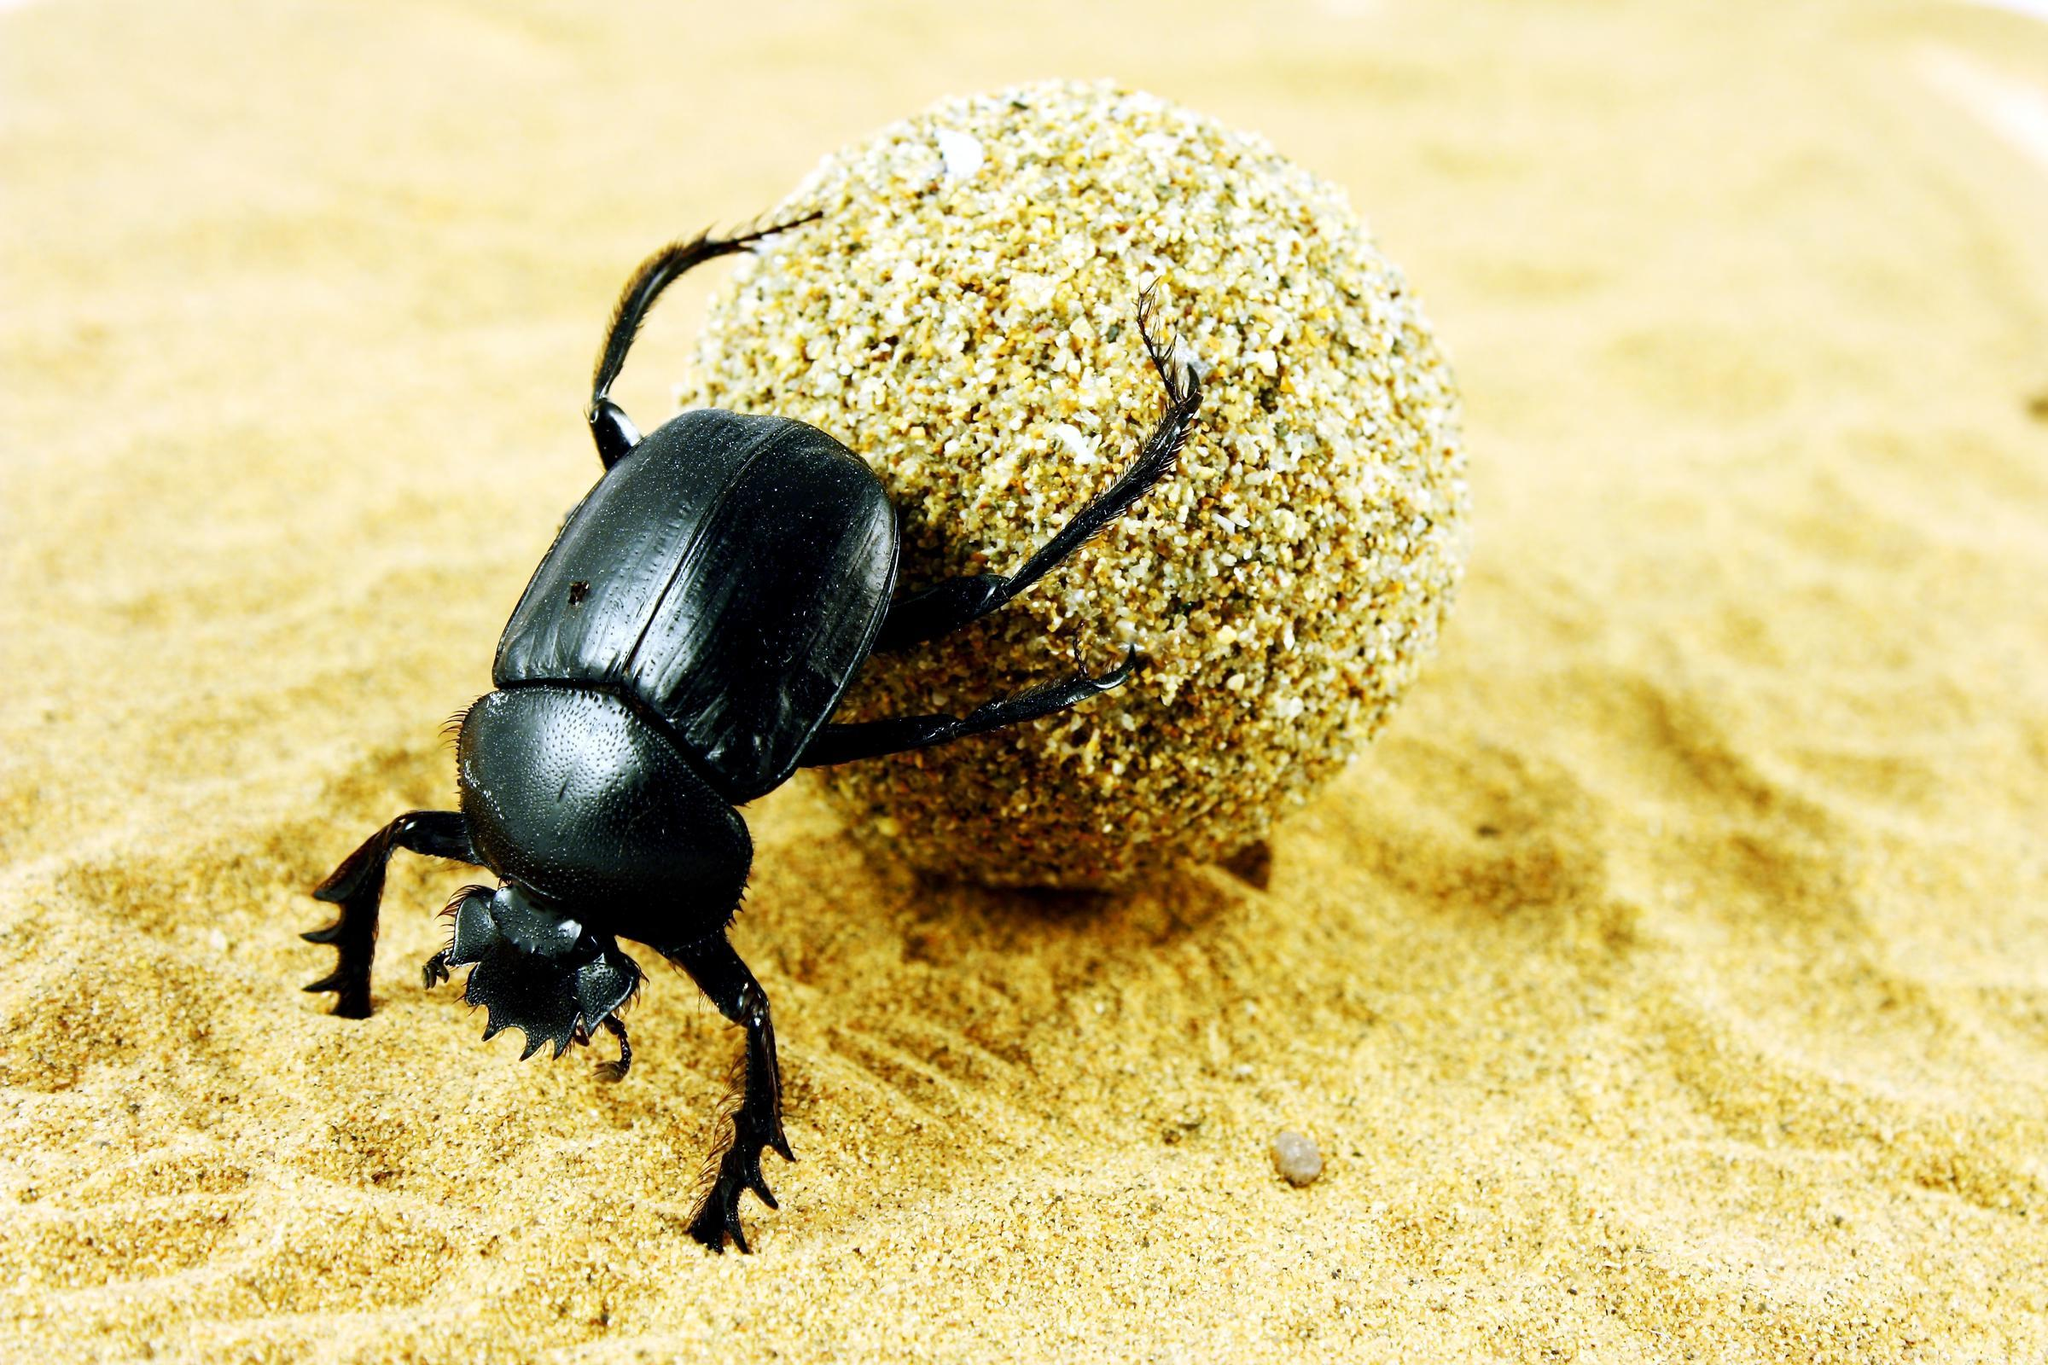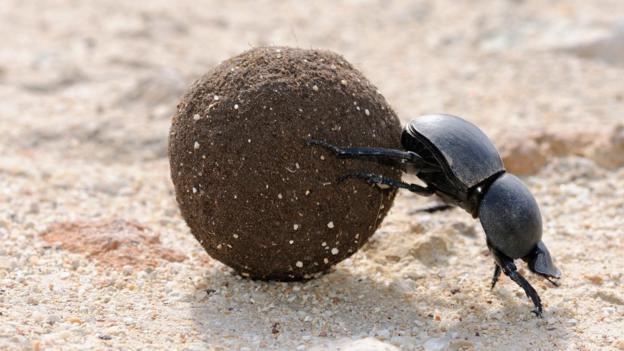The first image is the image on the left, the second image is the image on the right. For the images shown, is this caption "At least one of the beetles is not on a clod of dirt." true? Answer yes or no. No. The first image is the image on the left, the second image is the image on the right. For the images displayed, is the sentence "Both images show a beetle in contact with a round dung ball." factually correct? Answer yes or no. Yes. 